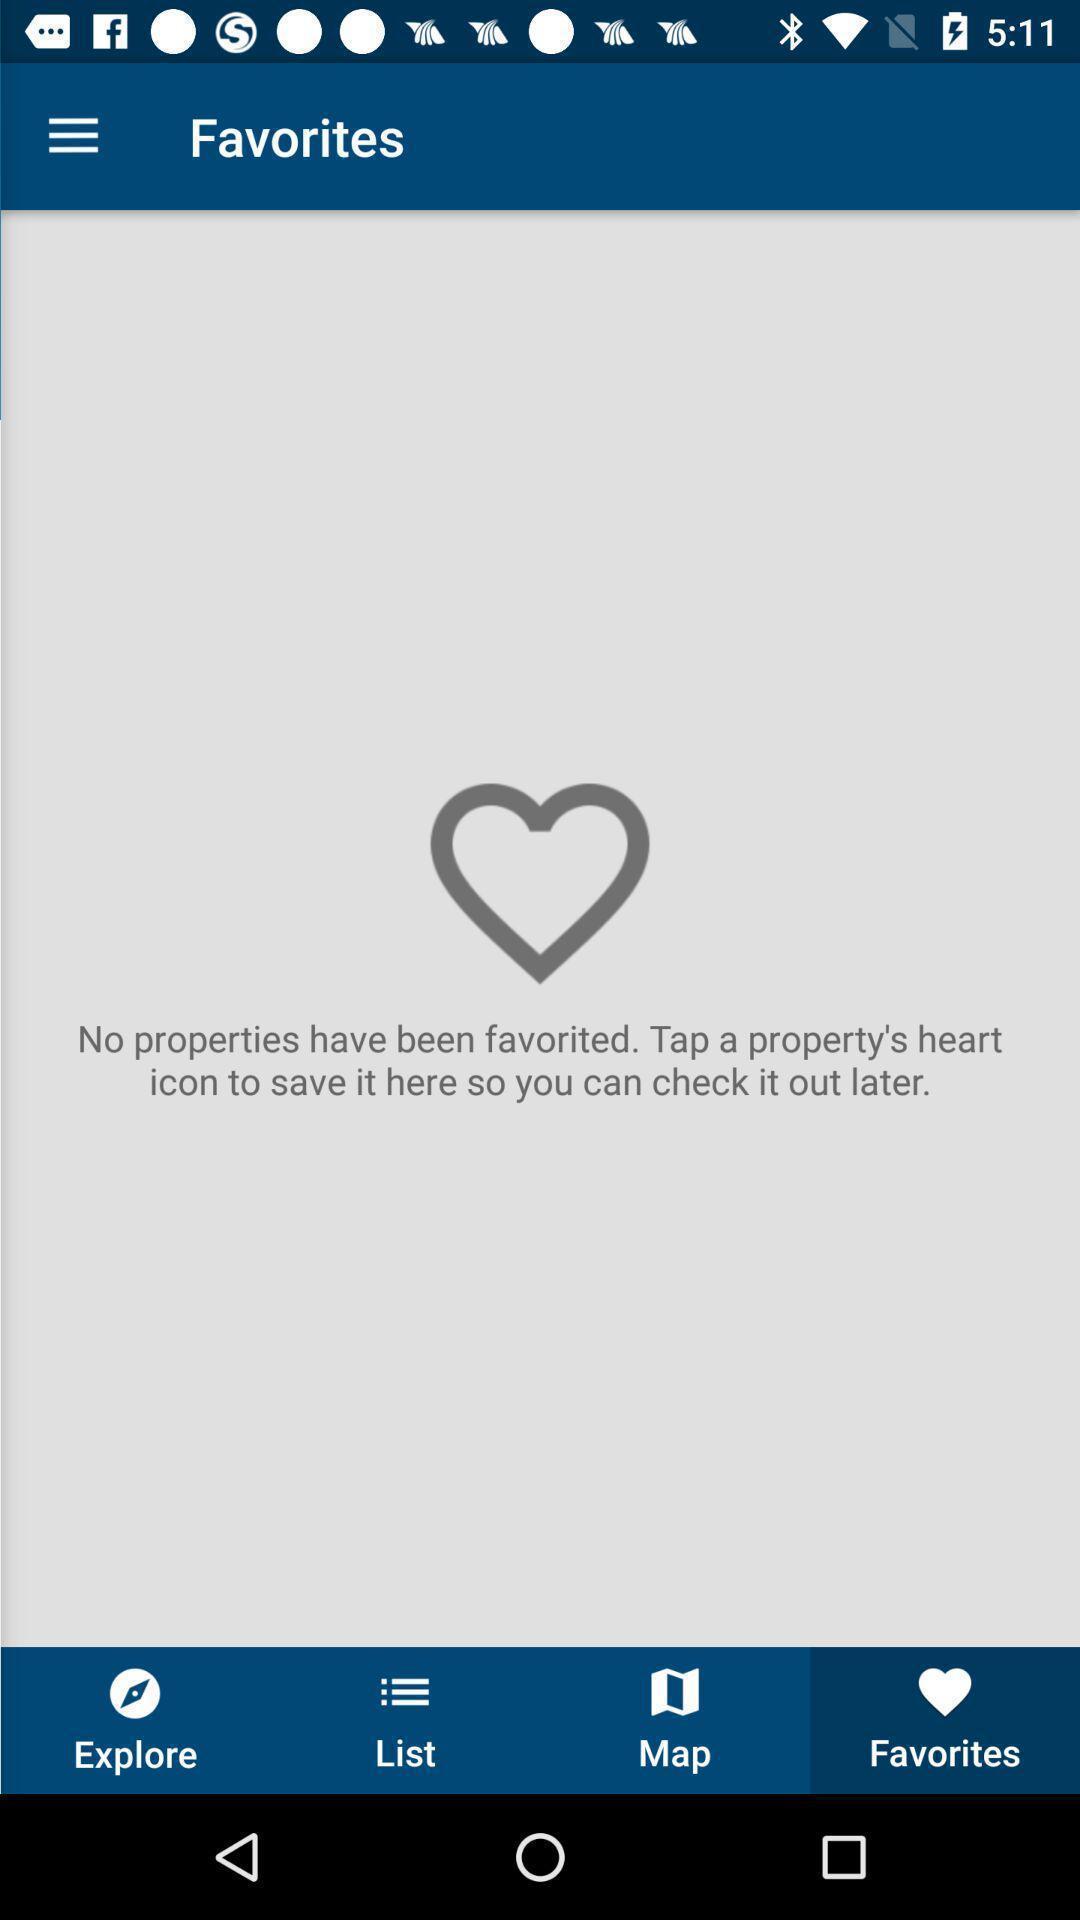Describe the content in this image. Screen displaying favorites page. 